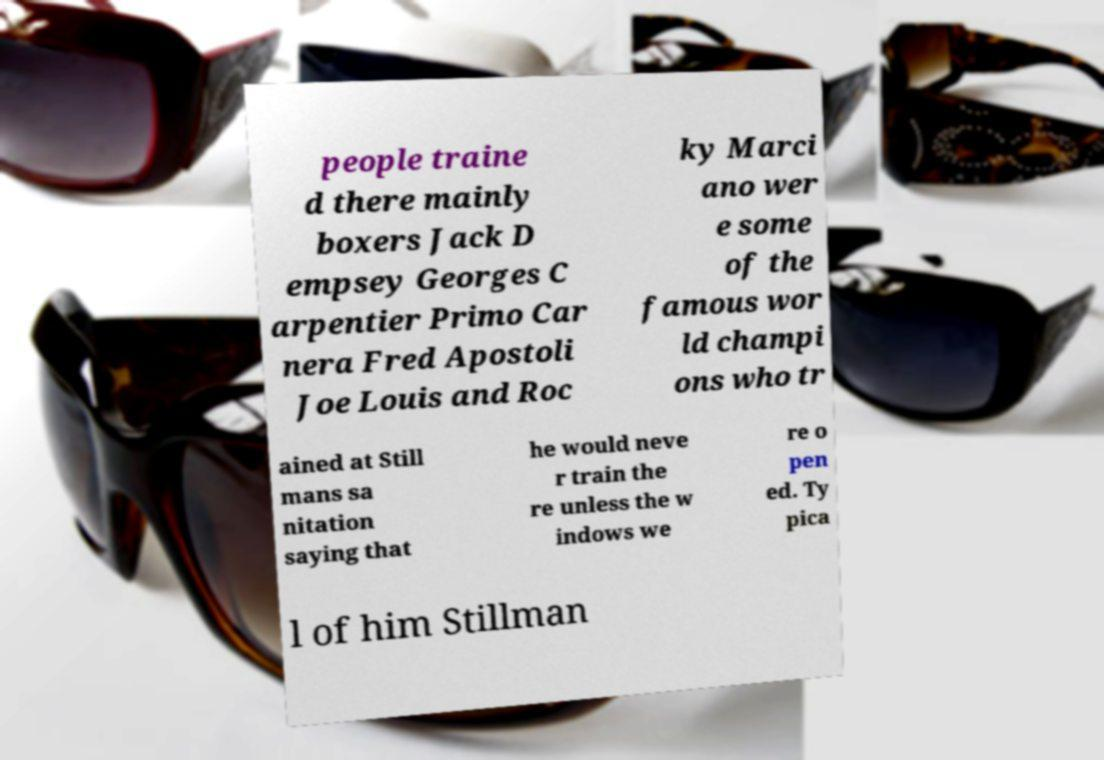Please identify and transcribe the text found in this image. people traine d there mainly boxers Jack D empsey Georges C arpentier Primo Car nera Fred Apostoli Joe Louis and Roc ky Marci ano wer e some of the famous wor ld champi ons who tr ained at Still mans sa nitation saying that he would neve r train the re unless the w indows we re o pen ed. Ty pica l of him Stillman 